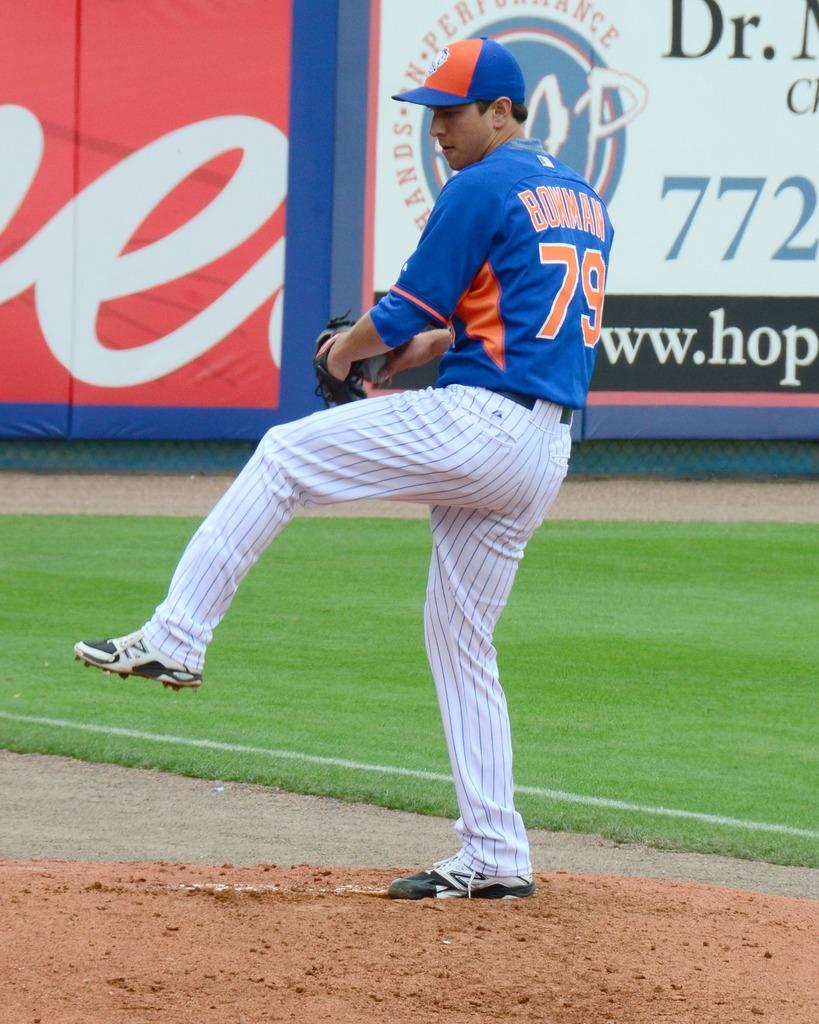<image>
Share a concise interpretation of the image provided. a player that has the number 79 on their jersey 